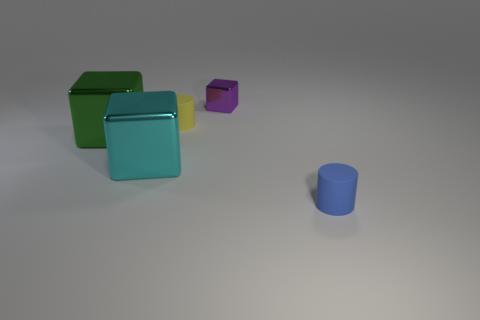What color is the other large metallic object that is the same shape as the green object?
Your response must be concise. Cyan. How many tiny matte cylinders are the same color as the tiny cube?
Provide a succinct answer. 0. Is the size of the cube to the right of the small yellow thing the same as the rubber thing right of the tiny yellow cylinder?
Keep it short and to the point. Yes. Is the size of the blue cylinder the same as the metallic thing behind the small yellow cylinder?
Provide a short and direct response. Yes. How big is the yellow cylinder?
Make the answer very short. Small. What color is the other thing that is the same material as the tiny blue object?
Offer a terse response. Yellow. What number of tiny yellow objects are the same material as the green cube?
Make the answer very short. 0. What number of things are tiny shiny things or objects that are on the right side of the tiny cube?
Your response must be concise. 2. Are the block that is to the left of the large cyan object and the yellow cylinder made of the same material?
Make the answer very short. No. The block that is the same size as the cyan thing is what color?
Your response must be concise. Green. 